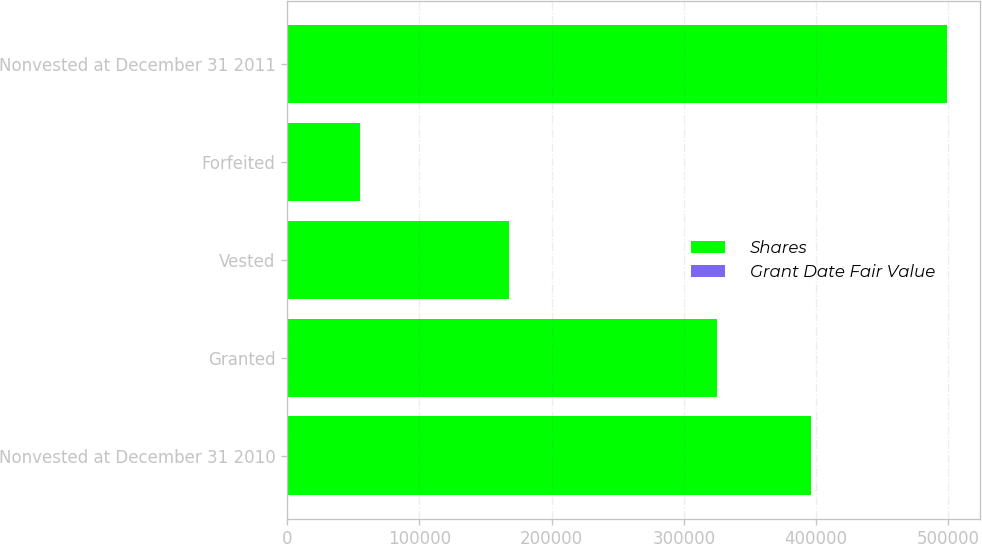Convert chart to OTSL. <chart><loc_0><loc_0><loc_500><loc_500><stacked_bar_chart><ecel><fcel>Nonvested at December 31 2010<fcel>Granted<fcel>Vested<fcel>Forfeited<fcel>Nonvested at December 31 2011<nl><fcel>Shares<fcel>395950<fcel>325447<fcel>167414<fcel>54864<fcel>499119<nl><fcel>Grant Date Fair Value<fcel>43.49<fcel>59.69<fcel>43.24<fcel>56.36<fcel>52.72<nl></chart> 